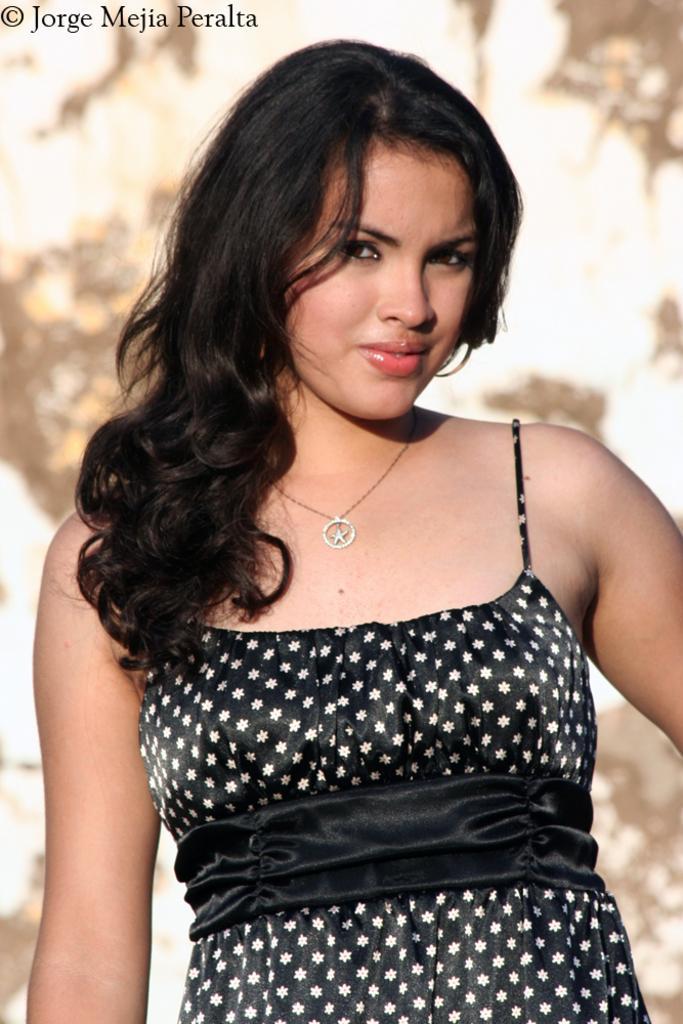Can you describe this image briefly? In the image there is a woman standing in the foreground and posing for the photo, the background of the woman is blur. 